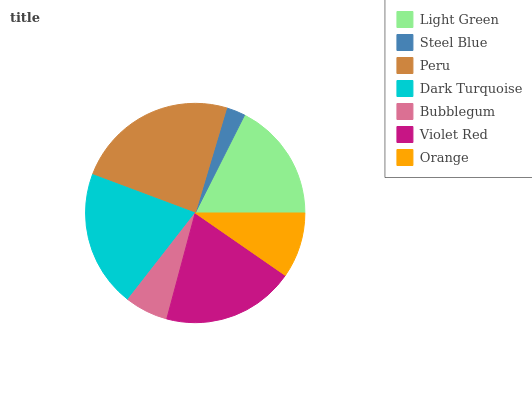Is Steel Blue the minimum?
Answer yes or no. Yes. Is Peru the maximum?
Answer yes or no. Yes. Is Peru the minimum?
Answer yes or no. No. Is Steel Blue the maximum?
Answer yes or no. No. Is Peru greater than Steel Blue?
Answer yes or no. Yes. Is Steel Blue less than Peru?
Answer yes or no. Yes. Is Steel Blue greater than Peru?
Answer yes or no. No. Is Peru less than Steel Blue?
Answer yes or no. No. Is Light Green the high median?
Answer yes or no. Yes. Is Light Green the low median?
Answer yes or no. Yes. Is Peru the high median?
Answer yes or no. No. Is Dark Turquoise the low median?
Answer yes or no. No. 